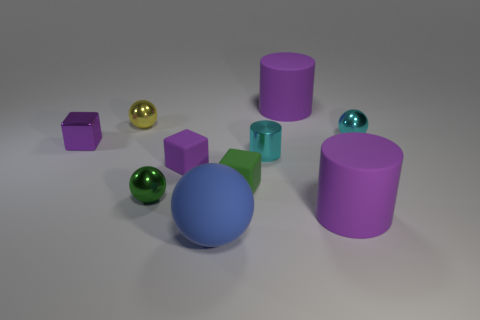There is a blue object; does it have the same size as the ball right of the big rubber sphere?
Offer a terse response. No. What color is the big thing that is behind the big cylinder in front of the tiny metal cylinder?
Your answer should be very brief. Purple. Are there an equal number of purple matte things that are right of the large blue ball and rubber objects to the left of the purple metallic thing?
Ensure brevity in your answer.  No. Does the purple thing that is to the left of the yellow ball have the same material as the cyan sphere?
Your answer should be compact. Yes. There is a cylinder that is both in front of the small yellow object and on the right side of the small cyan cylinder; what is its color?
Your answer should be very brief. Purple. What number of tiny metal spheres are behind the tiny cyan shiny cylinder on the right side of the small yellow metallic object?
Your answer should be very brief. 2. There is another purple object that is the same shape as the small purple metal object; what is it made of?
Keep it short and to the point. Rubber. What is the color of the metal cylinder?
Offer a very short reply. Cyan. What number of objects are tiny blue metallic cubes or small cyan metallic things?
Keep it short and to the point. 2. What is the shape of the cyan metal thing that is to the right of the purple matte cylinder in front of the tiny yellow object?
Your answer should be compact. Sphere. 